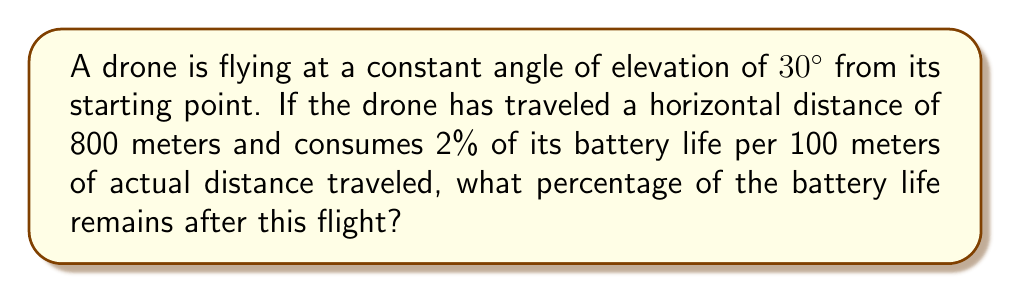Could you help me with this problem? Let's approach this step-by-step:

1) First, we need to find the actual distance traveled by the drone. We're given the horizontal distance, but the drone is flying at an angle.

2) We can use the cosine function to find the actual distance:
   
   $\cos 30° = \frac{\text{adjacent}}{\text{hypotenuse}} = \frac{800}{\text{actual distance}}$

3) Solving for the actual distance:
   
   $\text{actual distance} = \frac{800}{\cos 30°} = \frac{800}{\frac{\sqrt{3}}{2}} = \frac{1600}{\sqrt{3}} \approx 923.76$ meters

4) Now, we know that the drone consumes 2% of its battery life per 100 meters.

5) To find the percentage consumed, we set up this proportion:
   
   $\frac{2\%}{100\text{ m}} = \frac{x\%}{923.76\text{ m}}$

6) Cross multiply and solve for x:
   
   $x = \frac{2 \times 923.76}{100} \approx 18.48\%$

7) Therefore, the percentage of battery life consumed is approximately 18.48%.

8) The remaining battery life is:
   
   $100\% - 18.48\% = 81.52\%$
Answer: 81.52% 